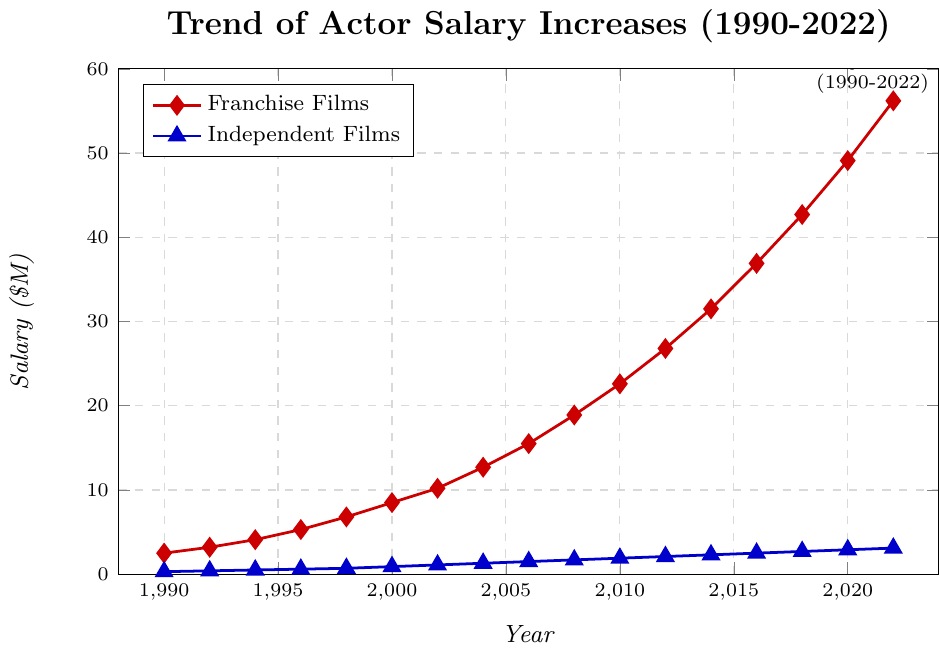Which year saw the highest salary for franchise films? Observe the maximum point on the red line representing franchise films. The highest salary is at the end of the timeline.
Answer: 2022 What was the difference in salary between franchise films and independent films in 2010? Locate the salaries for both franchise films and independent films in 2010. For franchise films, it is $22.6M, and for independent films, it's $1.9M. Subtract $1.9M from $22.6M.
Answer: $20.7M How did the salary for independent films change from 2000 to 2020? Identify the salaries for independent films in 2000 ($0.9M) and 2020 ($2.9M). Then calculate the difference: $2.9M - $0.9M.
Answer: Increased by $2M How many times higher was the salary for franchise films compared to independent films in 2022? For 2022, the franchise films salary is $56.2M and the independent films salary is $3.1M. Divide $56.2M by $3.1M.
Answer: 18.13 times What is the average salary for franchise films from 1990 to 2000? Add the salaries for franchise films from years 1990 ($2.5M), 1992 ($3.2M), 1994 ($4.1M), 1996 ($5.3M), 1998 ($6.8M), and 2000 ($8.5M). Divide the sum by the number of years (6). Calculation: ($2.5M + $3.2M + $4.1M + $5.3M + $6.8M + $8.5M) / 6.
Answer: $5.07M Between which consecutive years did franchise film salaries see the maximum increase? Calculate the differences between consecutive years: e.g., from 1990 to 1992 ($3.2M - $2.5M = $0.7M), from 1992 to 1994 ($4.1M - $3.2M = $0.9M), etc., and find the maximum difference. The year pair 2016 to 2018 shows the highest increase ($42.7M - $36.9M = $5.8M).
Answer: 2016 to 2018 During which period did both franchise and independent films see an increase in salary, but franchise films had a steeper increase? Identify periods where both lines are increasing but the red line (franchise films) has a steeper slope. From 2012 to 2020, both salaries increase, but the rise in franchise film salaries is more pronounced.
Answer: 2012 to 2020 Compare the trend of salary increase for franchise films with independent films between 1990 and 2000. Observe the overall trends for both lines between 1990 and 2000. Franchise films show a steady and steeper increase, while independent films exhibit a more gradual and slower rise.
Answer: Franchise films rose faster than independent films When did the salaries for franchise films first exceed $20M? Find the year where the red line (franchise films) first crosses the $20M salary mark. It happens around 2010.
Answer: 2010 